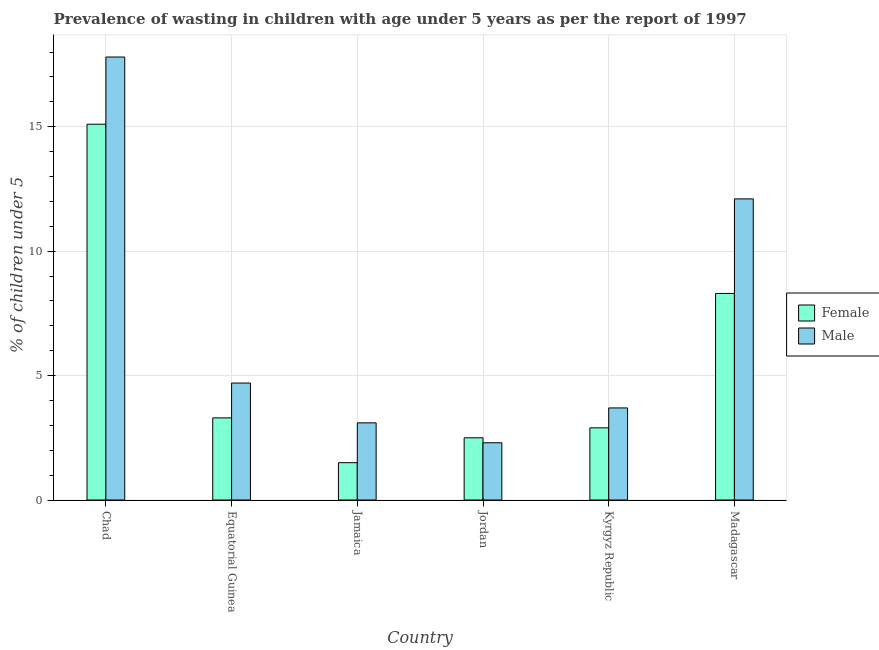Are the number of bars per tick equal to the number of legend labels?
Give a very brief answer. Yes. How many bars are there on the 6th tick from the right?
Your response must be concise. 2. What is the label of the 1st group of bars from the left?
Keep it short and to the point. Chad. In how many cases, is the number of bars for a given country not equal to the number of legend labels?
Offer a very short reply. 0. What is the percentage of undernourished male children in Kyrgyz Republic?
Your answer should be very brief. 3.7. Across all countries, what is the maximum percentage of undernourished female children?
Ensure brevity in your answer.  15.1. In which country was the percentage of undernourished female children maximum?
Ensure brevity in your answer.  Chad. In which country was the percentage of undernourished female children minimum?
Make the answer very short. Jamaica. What is the total percentage of undernourished female children in the graph?
Provide a succinct answer. 33.6. What is the difference between the percentage of undernourished male children in Equatorial Guinea and that in Jamaica?
Your answer should be compact. 1.6. What is the difference between the percentage of undernourished female children in Madagascar and the percentage of undernourished male children in Jamaica?
Make the answer very short. 5.2. What is the average percentage of undernourished male children per country?
Keep it short and to the point. 7.28. What is the difference between the percentage of undernourished male children and percentage of undernourished female children in Madagascar?
Make the answer very short. 3.8. What is the ratio of the percentage of undernourished female children in Equatorial Guinea to that in Kyrgyz Republic?
Provide a succinct answer. 1.14. Is the percentage of undernourished female children in Jamaica less than that in Kyrgyz Republic?
Your answer should be very brief. Yes. What is the difference between the highest and the second highest percentage of undernourished male children?
Your answer should be very brief. 5.7. What is the difference between the highest and the lowest percentage of undernourished female children?
Your response must be concise. 13.6. In how many countries, is the percentage of undernourished male children greater than the average percentage of undernourished male children taken over all countries?
Your answer should be compact. 2. How many bars are there?
Your response must be concise. 12. What is the difference between two consecutive major ticks on the Y-axis?
Ensure brevity in your answer.  5. Does the graph contain grids?
Provide a succinct answer. Yes. What is the title of the graph?
Offer a very short reply. Prevalence of wasting in children with age under 5 years as per the report of 1997. Does "Savings" appear as one of the legend labels in the graph?
Your response must be concise. No. What is the label or title of the Y-axis?
Your response must be concise.  % of children under 5. What is the  % of children under 5 in Female in Chad?
Your response must be concise. 15.1. What is the  % of children under 5 of Male in Chad?
Provide a succinct answer. 17.8. What is the  % of children under 5 of Female in Equatorial Guinea?
Your answer should be compact. 3.3. What is the  % of children under 5 of Male in Equatorial Guinea?
Make the answer very short. 4.7. What is the  % of children under 5 of Male in Jamaica?
Provide a succinct answer. 3.1. What is the  % of children under 5 of Female in Jordan?
Ensure brevity in your answer.  2.5. What is the  % of children under 5 in Male in Jordan?
Offer a terse response. 2.3. What is the  % of children under 5 in Female in Kyrgyz Republic?
Your answer should be compact. 2.9. What is the  % of children under 5 of Male in Kyrgyz Republic?
Your answer should be very brief. 3.7. What is the  % of children under 5 of Female in Madagascar?
Ensure brevity in your answer.  8.3. What is the  % of children under 5 of Male in Madagascar?
Keep it short and to the point. 12.1. Across all countries, what is the maximum  % of children under 5 in Female?
Keep it short and to the point. 15.1. Across all countries, what is the maximum  % of children under 5 in Male?
Your answer should be compact. 17.8. Across all countries, what is the minimum  % of children under 5 in Male?
Provide a short and direct response. 2.3. What is the total  % of children under 5 of Female in the graph?
Your answer should be compact. 33.6. What is the total  % of children under 5 of Male in the graph?
Your answer should be compact. 43.7. What is the difference between the  % of children under 5 in Female in Chad and that in Equatorial Guinea?
Provide a short and direct response. 11.8. What is the difference between the  % of children under 5 of Male in Chad and that in Equatorial Guinea?
Offer a very short reply. 13.1. What is the difference between the  % of children under 5 in Male in Chad and that in Jordan?
Provide a short and direct response. 15.5. What is the difference between the  % of children under 5 in Female in Chad and that in Kyrgyz Republic?
Your answer should be compact. 12.2. What is the difference between the  % of children under 5 of Female in Chad and that in Madagascar?
Your response must be concise. 6.8. What is the difference between the  % of children under 5 in Female in Equatorial Guinea and that in Jamaica?
Keep it short and to the point. 1.8. What is the difference between the  % of children under 5 in Male in Equatorial Guinea and that in Jamaica?
Provide a succinct answer. 1.6. What is the difference between the  % of children under 5 in Male in Equatorial Guinea and that in Jordan?
Make the answer very short. 2.4. What is the difference between the  % of children under 5 of Female in Equatorial Guinea and that in Kyrgyz Republic?
Make the answer very short. 0.4. What is the difference between the  % of children under 5 of Male in Equatorial Guinea and that in Kyrgyz Republic?
Provide a short and direct response. 1. What is the difference between the  % of children under 5 of Male in Equatorial Guinea and that in Madagascar?
Make the answer very short. -7.4. What is the difference between the  % of children under 5 of Male in Jamaica and that in Kyrgyz Republic?
Provide a succinct answer. -0.6. What is the difference between the  % of children under 5 of Female in Jamaica and that in Madagascar?
Offer a terse response. -6.8. What is the difference between the  % of children under 5 in Female in Jordan and that in Kyrgyz Republic?
Provide a short and direct response. -0.4. What is the difference between the  % of children under 5 of Male in Jordan and that in Kyrgyz Republic?
Give a very brief answer. -1.4. What is the difference between the  % of children under 5 in Female in Jordan and that in Madagascar?
Provide a succinct answer. -5.8. What is the difference between the  % of children under 5 in Female in Kyrgyz Republic and that in Madagascar?
Ensure brevity in your answer.  -5.4. What is the difference between the  % of children under 5 in Female in Chad and the  % of children under 5 in Male in Equatorial Guinea?
Give a very brief answer. 10.4. What is the difference between the  % of children under 5 in Female in Chad and the  % of children under 5 in Male in Kyrgyz Republic?
Ensure brevity in your answer.  11.4. What is the difference between the  % of children under 5 of Female in Chad and the  % of children under 5 of Male in Madagascar?
Offer a very short reply. 3. What is the difference between the  % of children under 5 of Female in Equatorial Guinea and the  % of children under 5 of Male in Kyrgyz Republic?
Make the answer very short. -0.4. What is the difference between the  % of children under 5 of Female in Jamaica and the  % of children under 5 of Male in Kyrgyz Republic?
Provide a short and direct response. -2.2. What is the difference between the  % of children under 5 of Female in Jordan and the  % of children under 5 of Male in Kyrgyz Republic?
Ensure brevity in your answer.  -1.2. What is the average  % of children under 5 of Male per country?
Keep it short and to the point. 7.28. What is the difference between the  % of children under 5 in Female and  % of children under 5 in Male in Jamaica?
Offer a very short reply. -1.6. What is the difference between the  % of children under 5 in Female and  % of children under 5 in Male in Jordan?
Offer a terse response. 0.2. What is the difference between the  % of children under 5 in Female and  % of children under 5 in Male in Kyrgyz Republic?
Your answer should be compact. -0.8. What is the difference between the  % of children under 5 of Female and  % of children under 5 of Male in Madagascar?
Offer a very short reply. -3.8. What is the ratio of the  % of children under 5 of Female in Chad to that in Equatorial Guinea?
Offer a terse response. 4.58. What is the ratio of the  % of children under 5 of Male in Chad to that in Equatorial Guinea?
Your answer should be compact. 3.79. What is the ratio of the  % of children under 5 of Female in Chad to that in Jamaica?
Provide a succinct answer. 10.07. What is the ratio of the  % of children under 5 of Male in Chad to that in Jamaica?
Give a very brief answer. 5.74. What is the ratio of the  % of children under 5 of Female in Chad to that in Jordan?
Offer a very short reply. 6.04. What is the ratio of the  % of children under 5 in Male in Chad to that in Jordan?
Provide a short and direct response. 7.74. What is the ratio of the  % of children under 5 of Female in Chad to that in Kyrgyz Republic?
Ensure brevity in your answer.  5.21. What is the ratio of the  % of children under 5 of Male in Chad to that in Kyrgyz Republic?
Offer a very short reply. 4.81. What is the ratio of the  % of children under 5 of Female in Chad to that in Madagascar?
Offer a very short reply. 1.82. What is the ratio of the  % of children under 5 in Male in Chad to that in Madagascar?
Your answer should be very brief. 1.47. What is the ratio of the  % of children under 5 in Female in Equatorial Guinea to that in Jamaica?
Make the answer very short. 2.2. What is the ratio of the  % of children under 5 in Male in Equatorial Guinea to that in Jamaica?
Your response must be concise. 1.52. What is the ratio of the  % of children under 5 in Female in Equatorial Guinea to that in Jordan?
Make the answer very short. 1.32. What is the ratio of the  % of children under 5 in Male in Equatorial Guinea to that in Jordan?
Your answer should be very brief. 2.04. What is the ratio of the  % of children under 5 in Female in Equatorial Guinea to that in Kyrgyz Republic?
Provide a succinct answer. 1.14. What is the ratio of the  % of children under 5 in Male in Equatorial Guinea to that in Kyrgyz Republic?
Your answer should be very brief. 1.27. What is the ratio of the  % of children under 5 of Female in Equatorial Guinea to that in Madagascar?
Offer a very short reply. 0.4. What is the ratio of the  % of children under 5 of Male in Equatorial Guinea to that in Madagascar?
Ensure brevity in your answer.  0.39. What is the ratio of the  % of children under 5 in Female in Jamaica to that in Jordan?
Provide a short and direct response. 0.6. What is the ratio of the  % of children under 5 in Male in Jamaica to that in Jordan?
Offer a terse response. 1.35. What is the ratio of the  % of children under 5 of Female in Jamaica to that in Kyrgyz Republic?
Ensure brevity in your answer.  0.52. What is the ratio of the  % of children under 5 of Male in Jamaica to that in Kyrgyz Republic?
Your answer should be compact. 0.84. What is the ratio of the  % of children under 5 of Female in Jamaica to that in Madagascar?
Your response must be concise. 0.18. What is the ratio of the  % of children under 5 of Male in Jamaica to that in Madagascar?
Offer a very short reply. 0.26. What is the ratio of the  % of children under 5 in Female in Jordan to that in Kyrgyz Republic?
Make the answer very short. 0.86. What is the ratio of the  % of children under 5 of Male in Jordan to that in Kyrgyz Republic?
Your answer should be very brief. 0.62. What is the ratio of the  % of children under 5 in Female in Jordan to that in Madagascar?
Provide a succinct answer. 0.3. What is the ratio of the  % of children under 5 in Male in Jordan to that in Madagascar?
Ensure brevity in your answer.  0.19. What is the ratio of the  % of children under 5 in Female in Kyrgyz Republic to that in Madagascar?
Your answer should be compact. 0.35. What is the ratio of the  % of children under 5 in Male in Kyrgyz Republic to that in Madagascar?
Give a very brief answer. 0.31. What is the difference between the highest and the second highest  % of children under 5 of Male?
Provide a short and direct response. 5.7. What is the difference between the highest and the lowest  % of children under 5 of Female?
Your answer should be very brief. 13.6. 